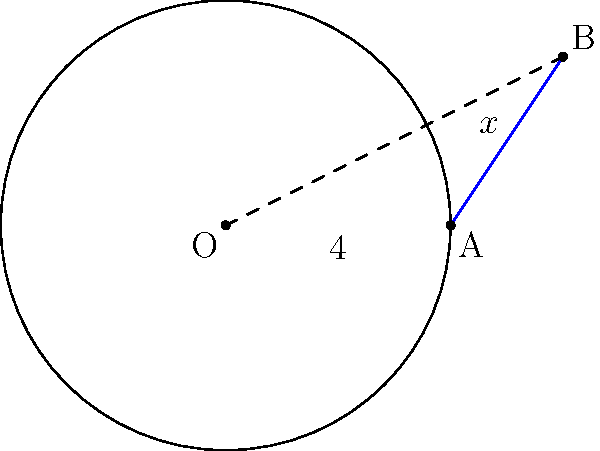In a recent government infrastructure project, a circular communication tower base is being planned with a radius of 4 meters. A power line needs to be connected from a nearby utility pole to a point on the circumference of the tower base. If the utility pole is located 6 meters from the center of the tower base and 3 meters perpendicular to the line connecting the center to the closest point on the circumference, what is the length of the power line needed to connect the utility pole to the tower base? Let's approach this step-by-step:

1) In the diagram, O represents the center of the circular tower base, A is the point on the circumference closest to the utility pole B.

2) We are given:
   - Radius of the circle (OA) = 4 meters
   - Distance from center to utility pole (OB) = $\sqrt{6^2 + 3^2} = \sqrt{45}$ meters

3) Let the length of the tangent line (AB) be $x$ meters.

4) In the right-angled triangle OAB:
   $OA^2 + AB^2 = OB^2$ (by the Pythagorean theorem)

5) Substituting the known values:
   $4^2 + x^2 = 45$

6) Simplifying:
   $16 + x^2 = 45$

7) Subtracting 16 from both sides:
   $x^2 = 29$

8) Taking the square root of both sides:
   $x = \sqrt{29}$

Therefore, the length of the power line needed is $\sqrt{29}$ meters.
Answer: $\sqrt{29}$ meters 